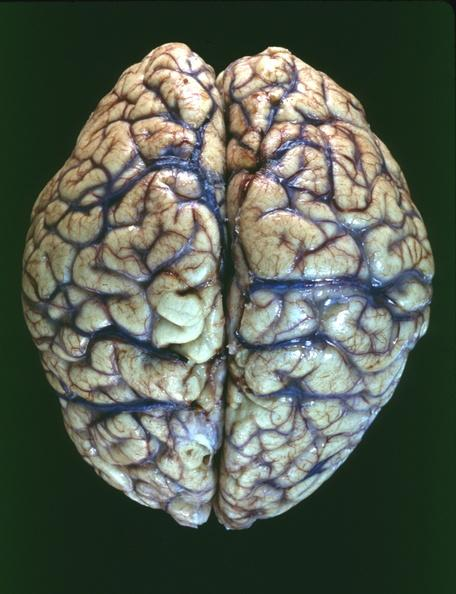s rheumatoid arthritis with vasculitis present?
Answer the question using a single word or phrase. No 